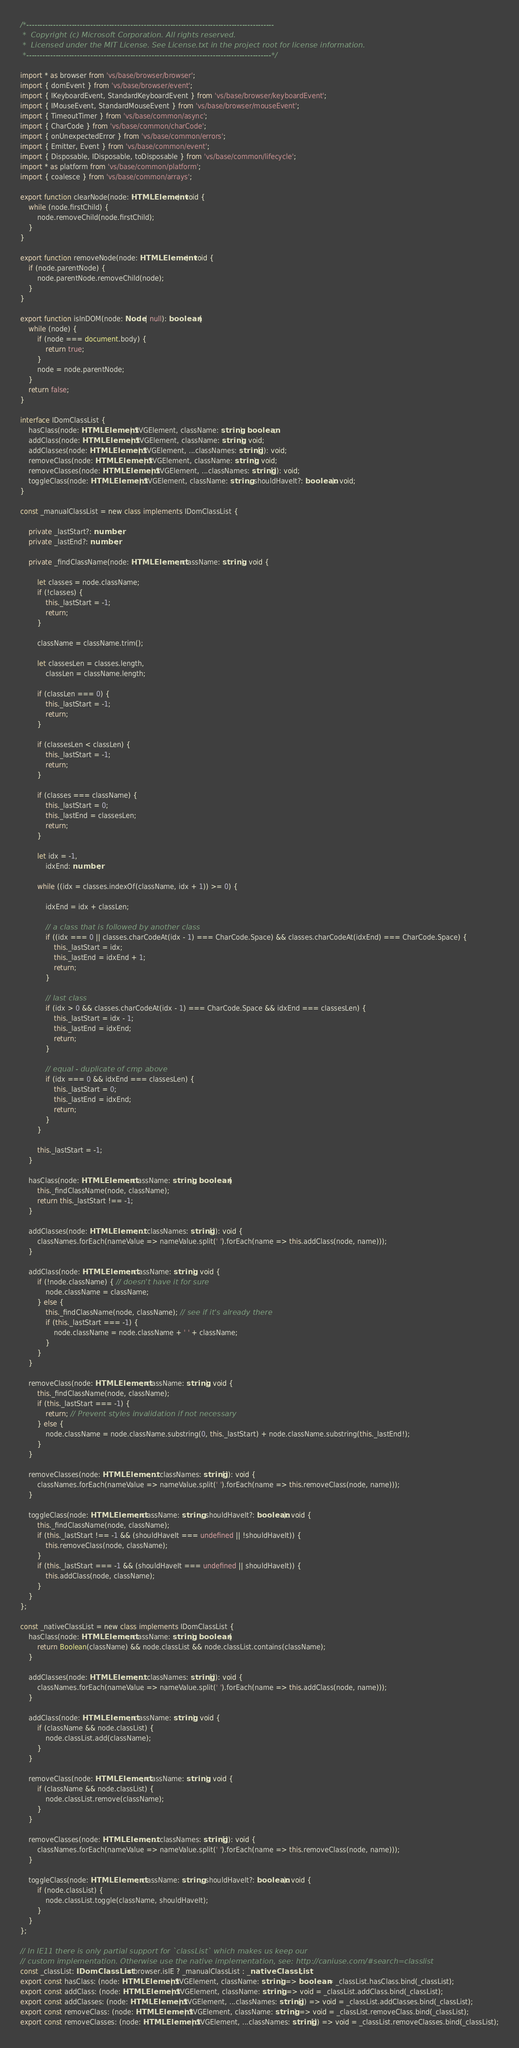<code> <loc_0><loc_0><loc_500><loc_500><_TypeScript_>/*---------------------------------------------------------------------------------------------
 *  Copyright (c) Microsoft Corporation. All rights reserved.
 *  Licensed under the MIT License. See License.txt in the project root for license information.
 *--------------------------------------------------------------------------------------------*/

import * as browser from 'vs/base/browser/browser';
import { domEvent } from 'vs/base/browser/event';
import { IKeyboardEvent, StandardKeyboardEvent } from 'vs/base/browser/keyboardEvent';
import { IMouseEvent, StandardMouseEvent } from 'vs/base/browser/mouseEvent';
import { TimeoutTimer } from 'vs/base/common/async';
import { CharCode } from 'vs/base/common/charCode';
import { onUnexpectedError } from 'vs/base/common/errors';
import { Emitter, Event } from 'vs/base/common/event';
import { Disposable, IDisposable, toDisposable } from 'vs/base/common/lifecycle';
import * as platform from 'vs/base/common/platform';
import { coalesce } from 'vs/base/common/arrays';

export function clearNode(node: HTMLElement): void {
	while (node.firstChild) {
		node.removeChild(node.firstChild);
	}
}

export function removeNode(node: HTMLElement): void {
	if (node.parentNode) {
		node.parentNode.removeChild(node);
	}
}

export function isInDOM(node: Node | null): boolean {
	while (node) {
		if (node === document.body) {
			return true;
		}
		node = node.parentNode;
	}
	return false;
}

interface IDomClassList {
	hasClass(node: HTMLElement | SVGElement, className: string): boolean;
	addClass(node: HTMLElement | SVGElement, className: string): void;
	addClasses(node: HTMLElement | SVGElement, ...classNames: string[]): void;
	removeClass(node: HTMLElement | SVGElement, className: string): void;
	removeClasses(node: HTMLElement | SVGElement, ...classNames: string[]): void;
	toggleClass(node: HTMLElement | SVGElement, className: string, shouldHaveIt?: boolean): void;
}

const _manualClassList = new class implements IDomClassList {

	private _lastStart?: number;
	private _lastEnd?: number;

	private _findClassName(node: HTMLElement, className: string): void {

		let classes = node.className;
		if (!classes) {
			this._lastStart = -1;
			return;
		}

		className = className.trim();

		let classesLen = classes.length,
			classLen = className.length;

		if (classLen === 0) {
			this._lastStart = -1;
			return;
		}

		if (classesLen < classLen) {
			this._lastStart = -1;
			return;
		}

		if (classes === className) {
			this._lastStart = 0;
			this._lastEnd = classesLen;
			return;
		}

		let idx = -1,
			idxEnd: number;

		while ((idx = classes.indexOf(className, idx + 1)) >= 0) {

			idxEnd = idx + classLen;

			// a class that is followed by another class
			if ((idx === 0 || classes.charCodeAt(idx - 1) === CharCode.Space) && classes.charCodeAt(idxEnd) === CharCode.Space) {
				this._lastStart = idx;
				this._lastEnd = idxEnd + 1;
				return;
			}

			// last class
			if (idx > 0 && classes.charCodeAt(idx - 1) === CharCode.Space && idxEnd === classesLen) {
				this._lastStart = idx - 1;
				this._lastEnd = idxEnd;
				return;
			}

			// equal - duplicate of cmp above
			if (idx === 0 && idxEnd === classesLen) {
				this._lastStart = 0;
				this._lastEnd = idxEnd;
				return;
			}
		}

		this._lastStart = -1;
	}

	hasClass(node: HTMLElement, className: string): boolean {
		this._findClassName(node, className);
		return this._lastStart !== -1;
	}

	addClasses(node: HTMLElement, ...classNames: string[]): void {
		classNames.forEach(nameValue => nameValue.split(' ').forEach(name => this.addClass(node, name)));
	}

	addClass(node: HTMLElement, className: string): void {
		if (!node.className) { // doesn't have it for sure
			node.className = className;
		} else {
			this._findClassName(node, className); // see if it's already there
			if (this._lastStart === -1) {
				node.className = node.className + ' ' + className;
			}
		}
	}

	removeClass(node: HTMLElement, className: string): void {
		this._findClassName(node, className);
		if (this._lastStart === -1) {
			return; // Prevent styles invalidation if not necessary
		} else {
			node.className = node.className.substring(0, this._lastStart) + node.className.substring(this._lastEnd!);
		}
	}

	removeClasses(node: HTMLElement, ...classNames: string[]): void {
		classNames.forEach(nameValue => nameValue.split(' ').forEach(name => this.removeClass(node, name)));
	}

	toggleClass(node: HTMLElement, className: string, shouldHaveIt?: boolean): void {
		this._findClassName(node, className);
		if (this._lastStart !== -1 && (shouldHaveIt === undefined || !shouldHaveIt)) {
			this.removeClass(node, className);
		}
		if (this._lastStart === -1 && (shouldHaveIt === undefined || shouldHaveIt)) {
			this.addClass(node, className);
		}
	}
};

const _nativeClassList = new class implements IDomClassList {
	hasClass(node: HTMLElement, className: string): boolean {
		return Boolean(className) && node.classList && node.classList.contains(className);
	}

	addClasses(node: HTMLElement, ...classNames: string[]): void {
		classNames.forEach(nameValue => nameValue.split(' ').forEach(name => this.addClass(node, name)));
	}

	addClass(node: HTMLElement, className: string): void {
		if (className && node.classList) {
			node.classList.add(className);
		}
	}

	removeClass(node: HTMLElement, className: string): void {
		if (className && node.classList) {
			node.classList.remove(className);
		}
	}

	removeClasses(node: HTMLElement, ...classNames: string[]): void {
		classNames.forEach(nameValue => nameValue.split(' ').forEach(name => this.removeClass(node, name)));
	}

	toggleClass(node: HTMLElement, className: string, shouldHaveIt?: boolean): void {
		if (node.classList) {
			node.classList.toggle(className, shouldHaveIt);
		}
	}
};

// In IE11 there is only partial support for `classList` which makes us keep our
// custom implementation. Otherwise use the native implementation, see: http://caniuse.com/#search=classlist
const _classList: IDomClassList = browser.isIE ? _manualClassList : _nativeClassList;
export const hasClass: (node: HTMLElement | SVGElement, className: string) => boolean = _classList.hasClass.bind(_classList);
export const addClass: (node: HTMLElement | SVGElement, className: string) => void = _classList.addClass.bind(_classList);
export const addClasses: (node: HTMLElement | SVGElement, ...classNames: string[]) => void = _classList.addClasses.bind(_classList);
export const removeClass: (node: HTMLElement | SVGElement, className: string) => void = _classList.removeClass.bind(_classList);
export const removeClasses: (node: HTMLElement | SVGElement, ...classNames: string[]) => void = _classList.removeClasses.bind(_classList);</code> 